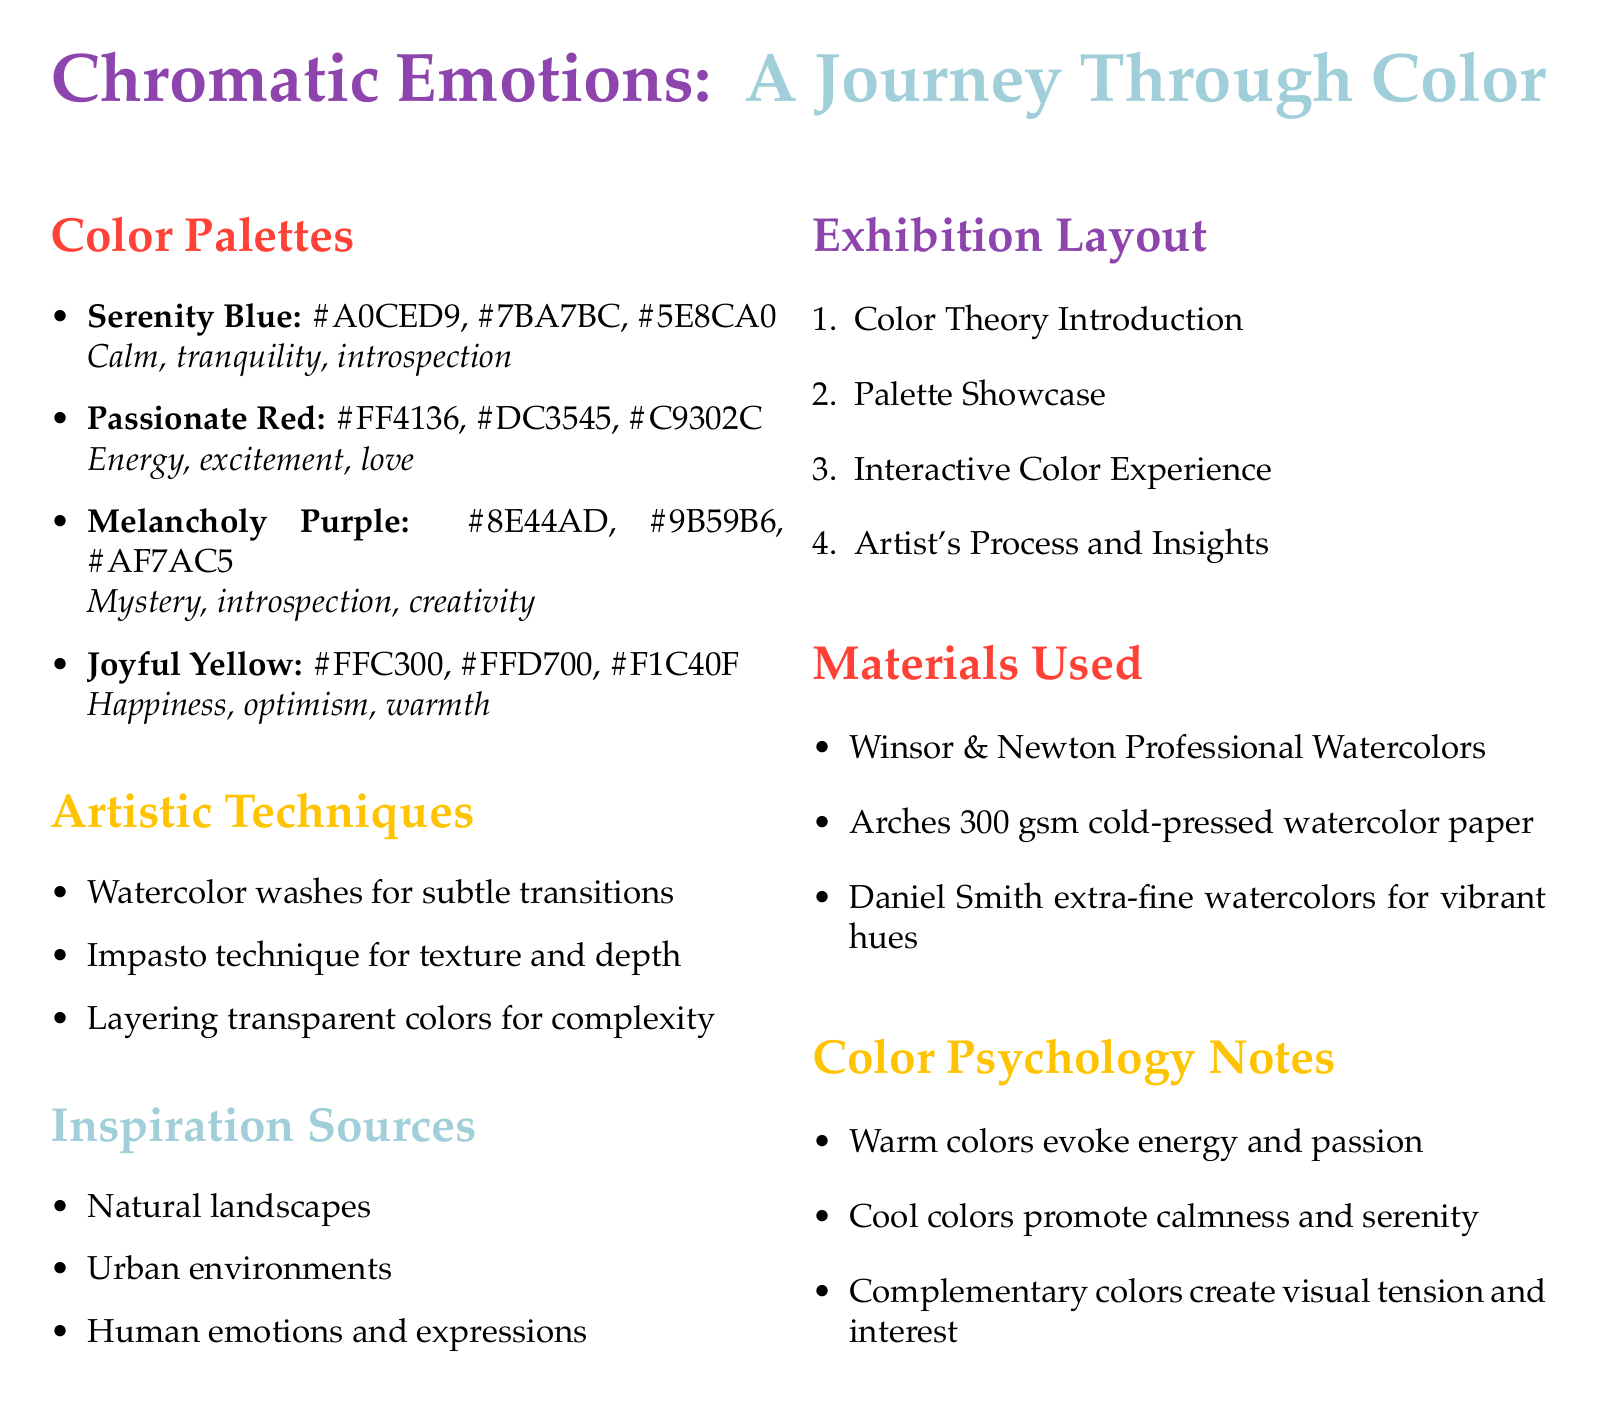What is the title of the exhibition? The title of the exhibition is listed at the beginning of the document.
Answer: Chromatic Emotions: A Journey Through Color How many color palettes are presented? The document specifies the number of color palettes in the Color Palettes section.
Answer: Four What emotions are associated with Joyful Yellow? The emotional impact of Joyful Yellow is noted in the document.
Answer: Happiness, optimism, warmth Name one artistic technique mentioned in the document. The document includes a list of artistic techniques used in the exhibition.
Answer: Watercolor washes for subtle transitions What is a source of inspiration for the color palettes? The document outlines sources of inspiration in a dedicated section.
Answer: Natural landscapes Which color is related to energy and love? The emotional impact of Passionate Red highlights its associations.
Answer: Passionate Red What type of paper is mentioned for use in the exhibition? The Materials Used section of the document lists specific materials, including the type of paper.
Answer: Arches 300 gsm cold-pressed watercolor paper Name a color psychology note provided in the document. The document contains notes on color psychology related to emotional impacts.
Answer: Warm colors evoke energy and passion 